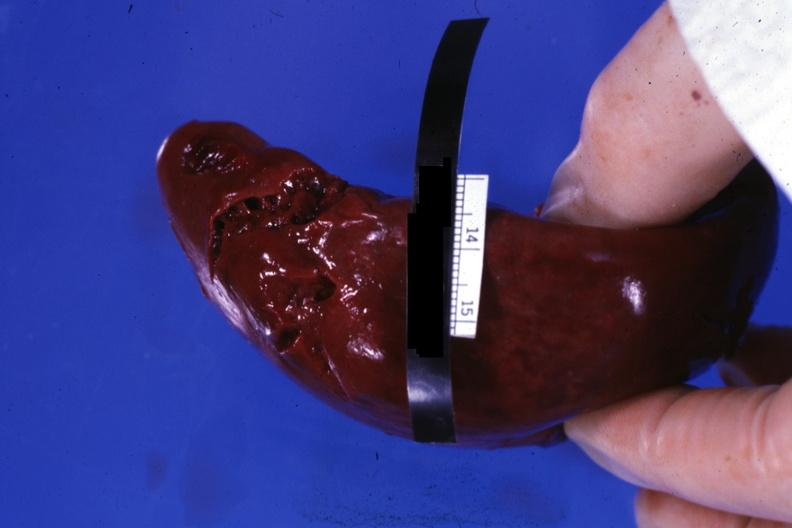s 70yof present?
Answer the question using a single word or phrase. No 